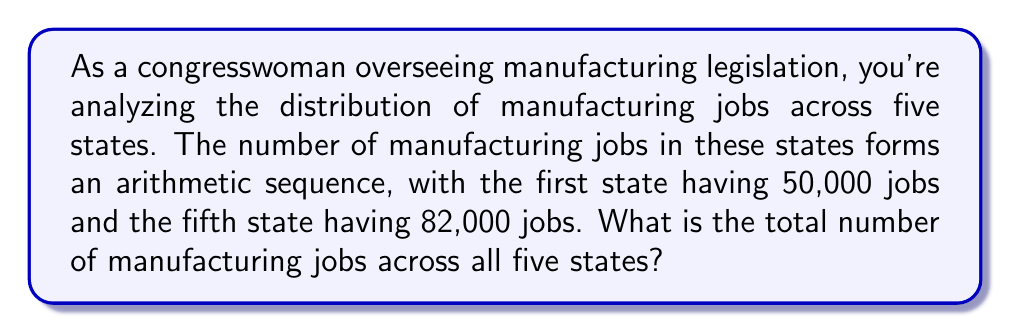Can you answer this question? Let's approach this step-by-step:

1) In an arithmetic sequence, the difference between each term is constant. Let's call this common difference $d$.

2) We're given that the first term $a_1 = 50,000$ and the fifth term $a_5 = 82,000$.

3) In an arithmetic sequence, the nth term is given by:
   $a_n = a_1 + (n-1)d$

4) We can use this to set up an equation:
   $82,000 = 50,000 + (5-1)d$
   $82,000 = 50,000 + 4d$

5) Solving for $d$:
   $32,000 = 4d$
   $d = 8,000$

6) Now we know the sequence: 50,000, 58,000, 66,000, 74,000, 82,000

7) To find the total, we need to sum this arithmetic sequence. The formula for the sum of an arithmetic sequence is:

   $S_n = \frac{n}{2}(a_1 + a_n)$

   Where $n$ is the number of terms, $a_1$ is the first term, and $a_n$ is the last term.

8) Plugging in our values:
   $S_5 = \frac{5}{2}(50,000 + 82,000)$
   $S_5 = \frac{5}{2}(132,000)$
   $S_5 = 330,000$

Therefore, the total number of manufacturing jobs across all five states is 330,000.
Answer: 330,000 manufacturing jobs 